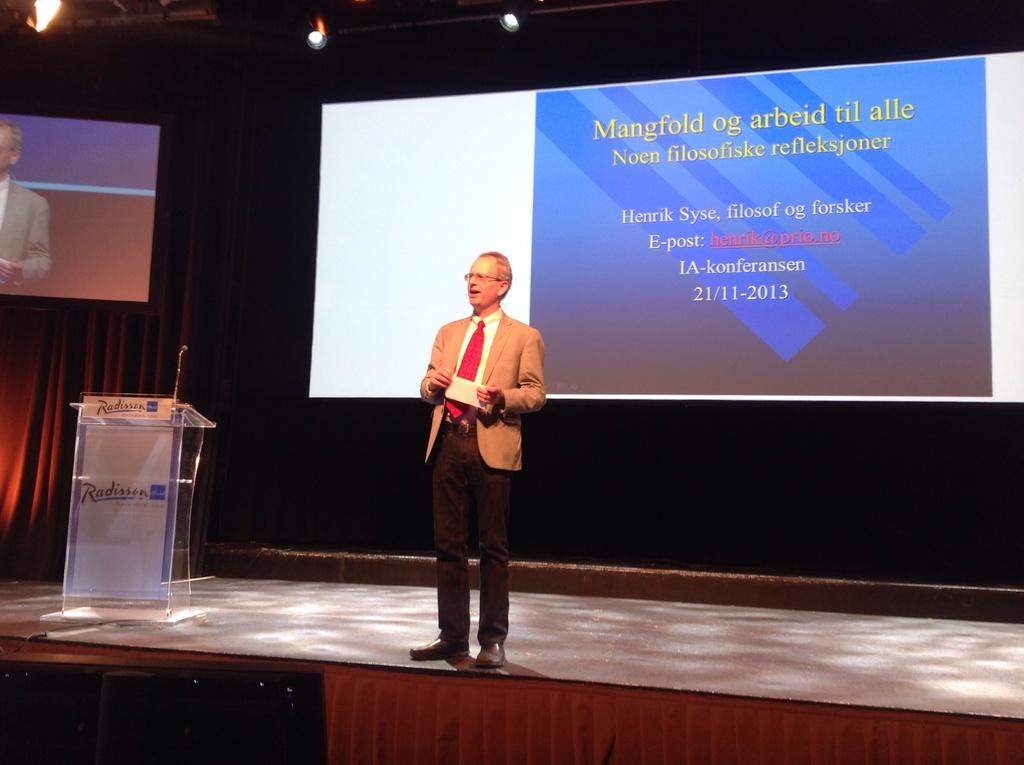<image>
Write a terse but informative summary of the picture. A man is speaking on a stage in front of viewing screem for an event that takes place on 21/11/2013. 